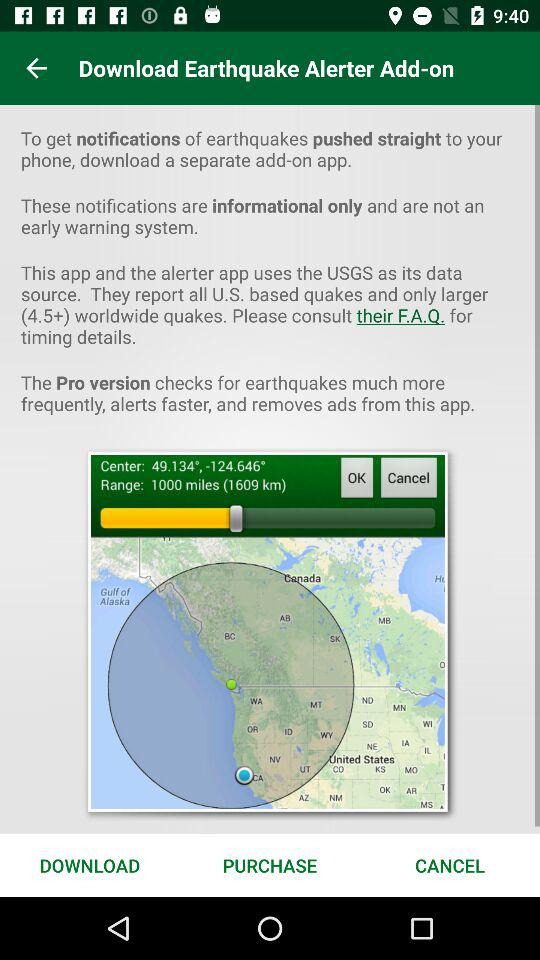What is the center of the earthquake? The center of the earthquake is 49.134°, -124.646°. 